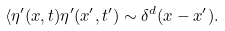<formula> <loc_0><loc_0><loc_500><loc_500>\langle \eta ^ { \prime } ( x , t ) \eta ^ { \prime } ( x ^ { \prime } , t ^ { \prime } ) \sim \delta ^ { d } ( x - x ^ { \prime } ) .</formula> 